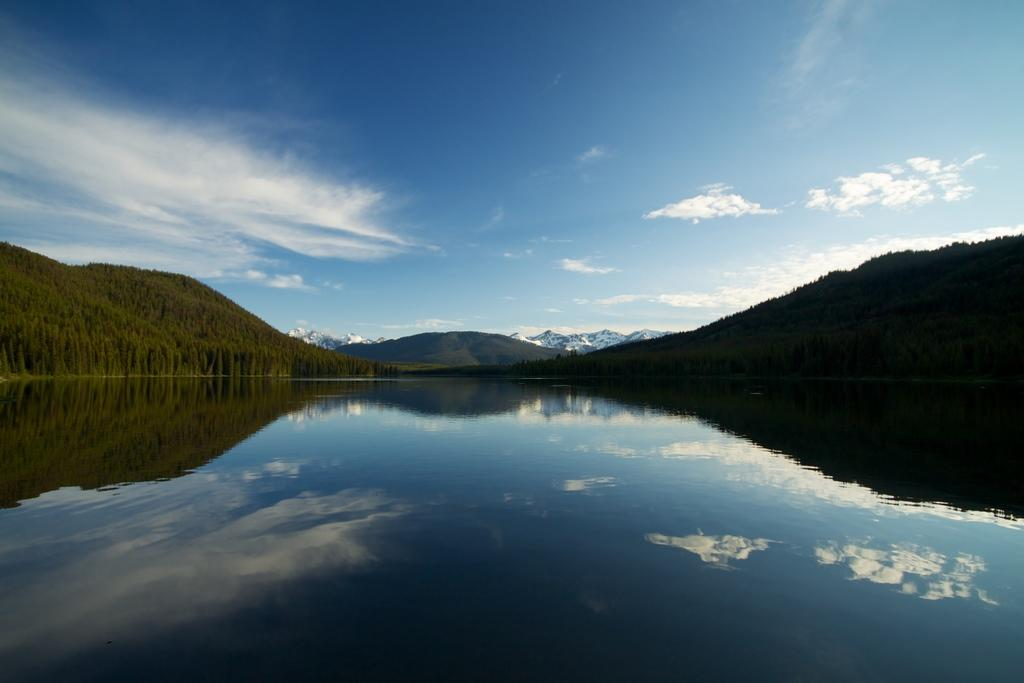What is visible in the image that is not solid? Water is visible in the image and is not solid. What type of vegetation can be seen in the image? Trees are present in the image. What geographical feature is visible in the background of the image? Hills are visible in the background of the image. What is visible in the sky in the image? Clouds are present in the sky. What type of corn is growing in the image? There is no corn present in the image. How many planes can be seen flying in the image? There are no planes visible in the image. 